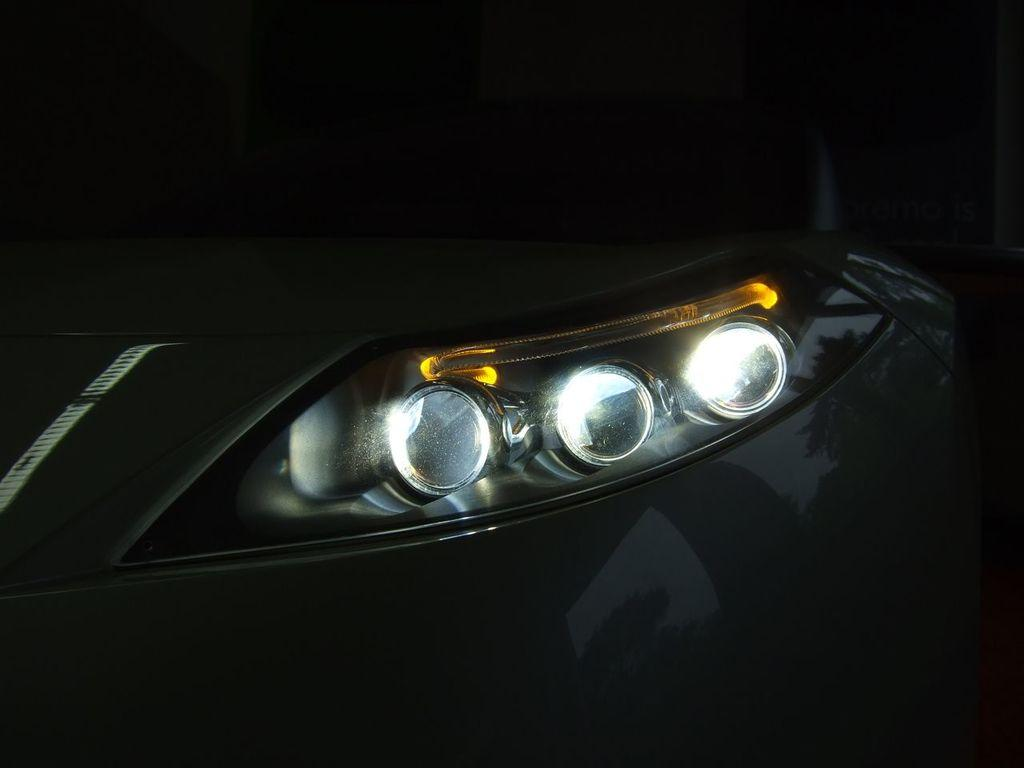What can be seen in the image that provides illumination? There are lights in the image. What is the main subject or object in the image? There is an unspecified object in the image. How would you describe the overall appearance of the image? The background of the image is dark. How many pets are visible in the image? There are no pets present in the image. What happens in the image over the course of a minute? The image is a still image, so no events or changes occur over time. 